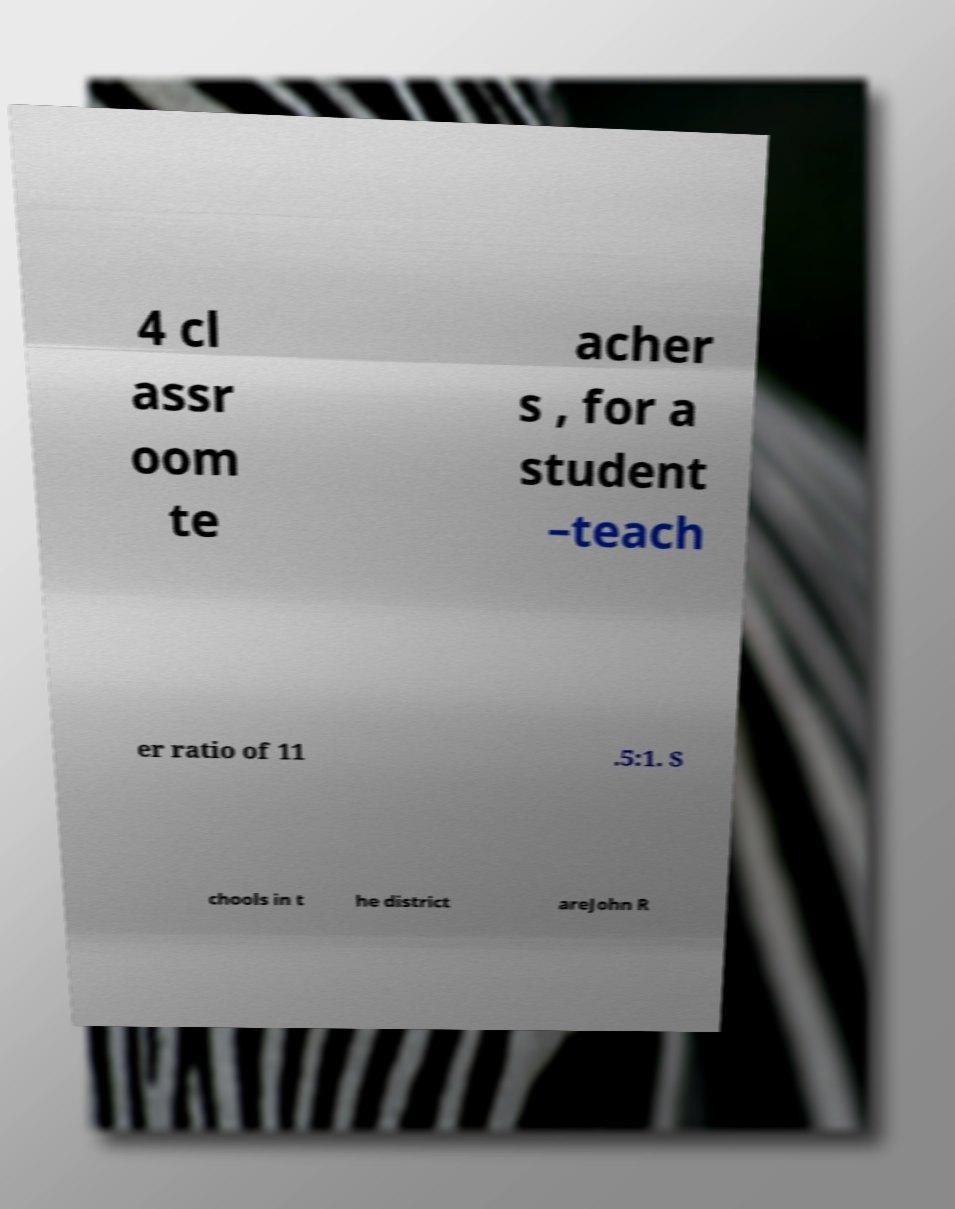Please identify and transcribe the text found in this image. 4 cl assr oom te acher s , for a student –teach er ratio of 11 .5:1. S chools in t he district areJohn R 